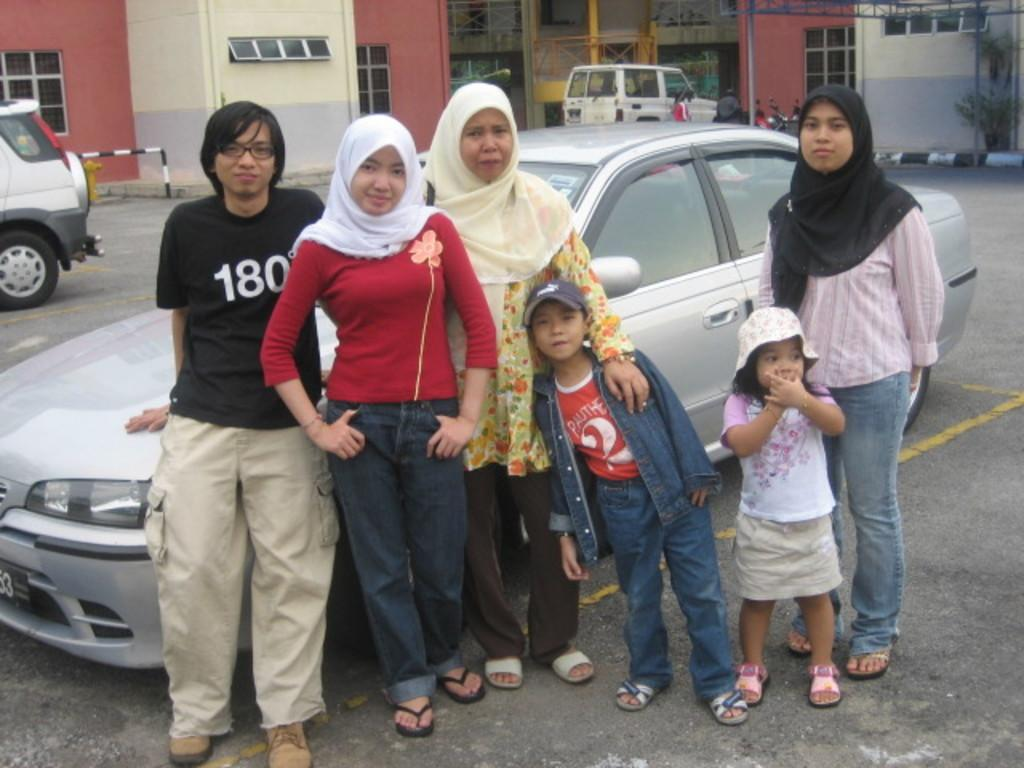What is happening in the image? There are many persons standing on the road in the image. What can be seen in the background of the image? There are cars, vehicles, plants, and at least one building in the background of the image. What type of appliance is being used by the persons standing on the road in the image? There is no appliance visible in the image; the persons are standing on the road without any appliances. 